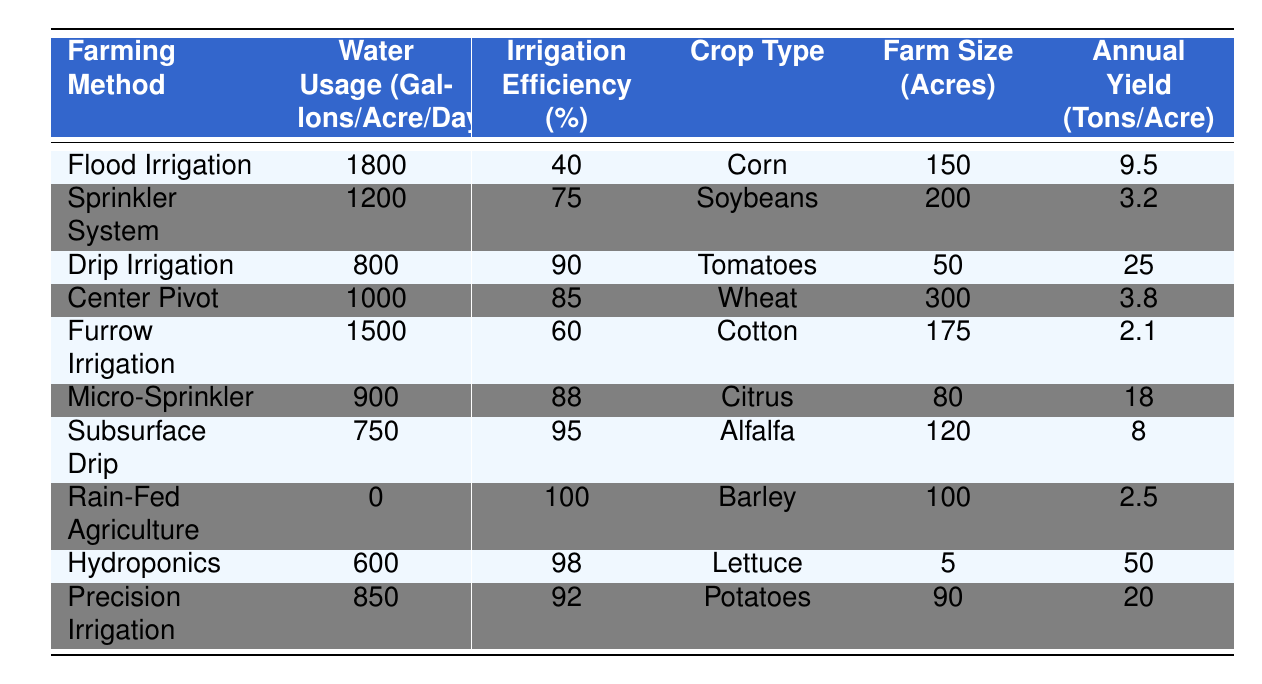What is the least water usage method from the table? In the table, I need to find the lowest value in the "Water Usage (Gallons/Acre/Day)" column. Scanning through the values, the lowest is 0, which corresponds to "Rain-Fed Agriculture."
Answer: Rain-Fed Agriculture Which farming method has the highest irrigation efficiency? To find the highest irrigation efficiency, I look through the "Irrigation Efficiency (%)" column. The maximum value is 100%, which is associated with "Rain-Fed Agriculture."
Answer: Rain-Fed Agriculture How many acres does the Drip Irrigation method cover? Looking in the "Farm Size (Acres)" column for the "Drip Irrigation" row, I find the corresponding value is 50 acres.
Answer: 50 acres What is the annual yield for the Micro-Sprinkler method? Referring to the "Annual Yield (Tons/Acre)" column, the value for "Micro-Sprinkler" is 18 tons per acre.
Answer: 18 tons What is the average water usage of all the farming methods listed? I need to sum the water usage values: (1800 + 1200 + 800 + 1000 + 1500 + 900 + 750 + 0 + 600 + 850) = 6000. Then, I divide that by the number of methods, which is 10, to find the average: 6000 / 10 = 600.
Answer: 600 gallons Is the irrigation efficiency of Drip Irrigation higher than that of Flood Irrigation? For this, I compare the "Irrigation Efficiency (%)" values for both methods: Drip Irrigation is 90% and Flood Irrigation is 40%. Since 90% is greater than 40%, the answer is yes.
Answer: Yes Calculate the total annual yield for all farming methods combined. To find the total annual yield, I add up the yields: (9.5 * 150) + (3.2 * 200) + (25 * 50) + (3.8 * 300) + (2.1 * 175) + (18 * 80) + (8 * 120) + (2.5 * 100) + (50 * 5) + (20 * 90) = 1425 + 640 + 1250 + 1140 + 367.5 + 1440 + 960 + 250 + 250 + 1800 = 6062.5 tons.
Answer: 6062.5 tons Which crop type has the highest annual yield per acre? I need to find the maximum value in the "Annual Yield (Tons/Acre)" column, which is 50 tons, corresponding to "Lettuce."
Answer: Lettuce What is the difference in water usage between Furrow Irrigation and Subsurface Drip? For this, I subtract the water usage of Subsurface Drip (750 gallons) from that of Furrow Irrigation (1500 gallons): 1500 - 750 = 750 gallons.
Answer: 750 gallons If we were to prioritize irrigation methods based on efficiency, which two methods would be chosen? I will first identify the top two values in the "Irrigation Efficiency (%)" column. The highest is 100% (Rain-Fed Agriculture) and the second is 98% (Hydroponics). Therefore, the methods chosen would be Rain-Fed Agriculture and Hydroponics.
Answer: Rain-Fed Agriculture and Hydroponics 